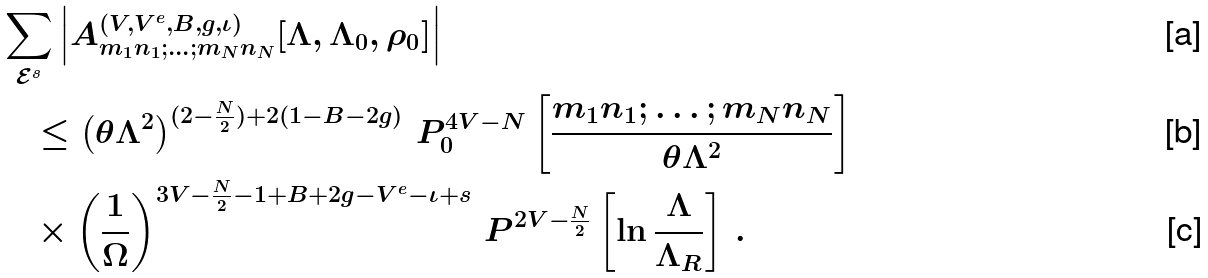<formula> <loc_0><loc_0><loc_500><loc_500>& \sum _ { \mathcal { E } ^ { s } } \left | A ^ { ( V , V ^ { e } , B , g , \iota ) } _ { m _ { 1 } n _ { 1 } ; \dots ; m _ { N } n _ { N } } [ \Lambda , \Lambda _ { 0 } , \rho _ { 0 } ] \right | \\ & \quad \leq \left ( \theta \Lambda ^ { 2 } \right ) ^ { ( 2 - \frac { N } { 2 } ) + 2 ( 1 - B - 2 g ) } \, P ^ { 4 V - N } _ { 0 } \left [ \frac { m _ { 1 } n _ { 1 } ; \dots ; m _ { N } n _ { N } } { \theta \Lambda ^ { 2 } } \right ] \\ & \quad \times \left ( \frac { 1 } { \Omega } \right ) ^ { 3 V - \frac { N } { 2 } - 1 + B + 2 g - V ^ { e } - \iota + s } \, P ^ { 2 V - \frac { N } { 2 } } \left [ \ln \frac { \Lambda } { \Lambda _ { R } } \right ] \, .</formula> 